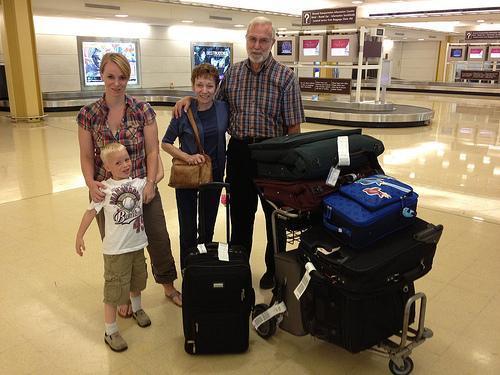How many people are there?
Give a very brief answer. 4. How many females are there?
Give a very brief answer. 2. How many children are there?
Give a very brief answer. 1. 